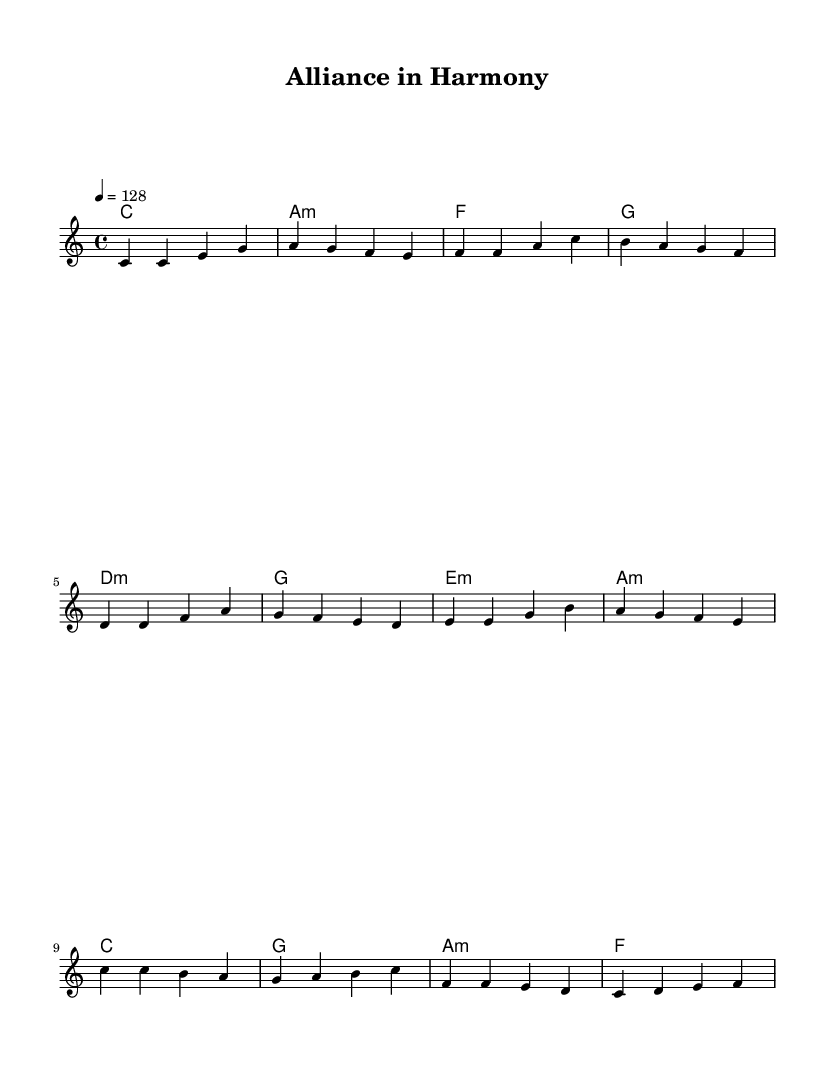What is the key signature of this music? The key signature displayed is C major, which is indicated by the absence of sharps or flats.
Answer: C major What is the time signature of the piece? The time signature shown is 4/4, which means there are four beats per measure, and each quarter note receives one beat.
Answer: 4/4 What is the tempo marked in the score? The tempo marking is 128 beats per minute, which is indicated at the beginning of the score with "4 = 128".
Answer: 128 How many lines are in the verse lyrics? The verse lyrics have four lines, as they are organized into a group of four phrases before moving to the prechorus.
Answer: Four What is the tonic chord in the song's chorus? The tonic chord in the chorus is C major, which is the first chord of the chorus progression and aligns with the key signature.
Answer: C What type of song structure is used in this piece? The song follows a common pop song structure that includes a verse, prechorus, and chorus, reflecting a typical arrangement in upbeat pop music.
Answer: Verse, prechorus, chorus What is the primary theme reflected in the lyrics? The primary theme reflected in the lyrics revolves around international unity, cooperation, and the strength of alliances in the context of geopolitics.
Answer: Unity and alliances 